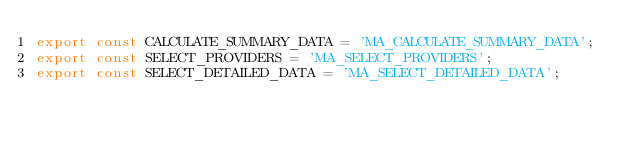<code> <loc_0><loc_0><loc_500><loc_500><_JavaScript_>export const CALCULATE_SUMMARY_DATA = 'MA_CALCULATE_SUMMARY_DATA';
export const SELECT_PROVIDERS = 'MA_SELECT_PROVIDERS';
export const SELECT_DETAILED_DATA = 'MA_SELECT_DETAILED_DATA';
</code> 